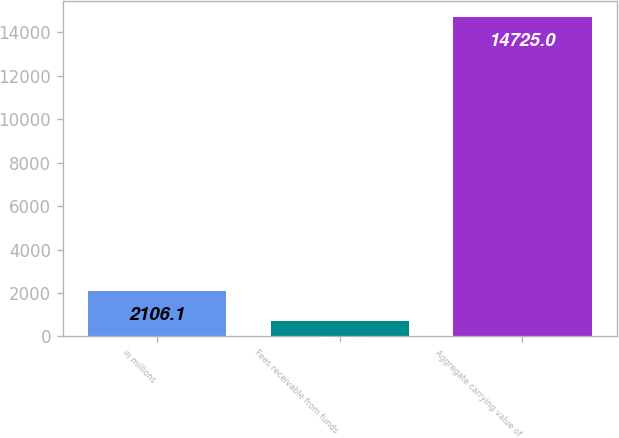Convert chart to OTSL. <chart><loc_0><loc_0><loc_500><loc_500><bar_chart><fcel>in millions<fcel>Fees receivable from funds<fcel>Aggregate carrying value of<nl><fcel>2106.1<fcel>704<fcel>14725<nl></chart> 